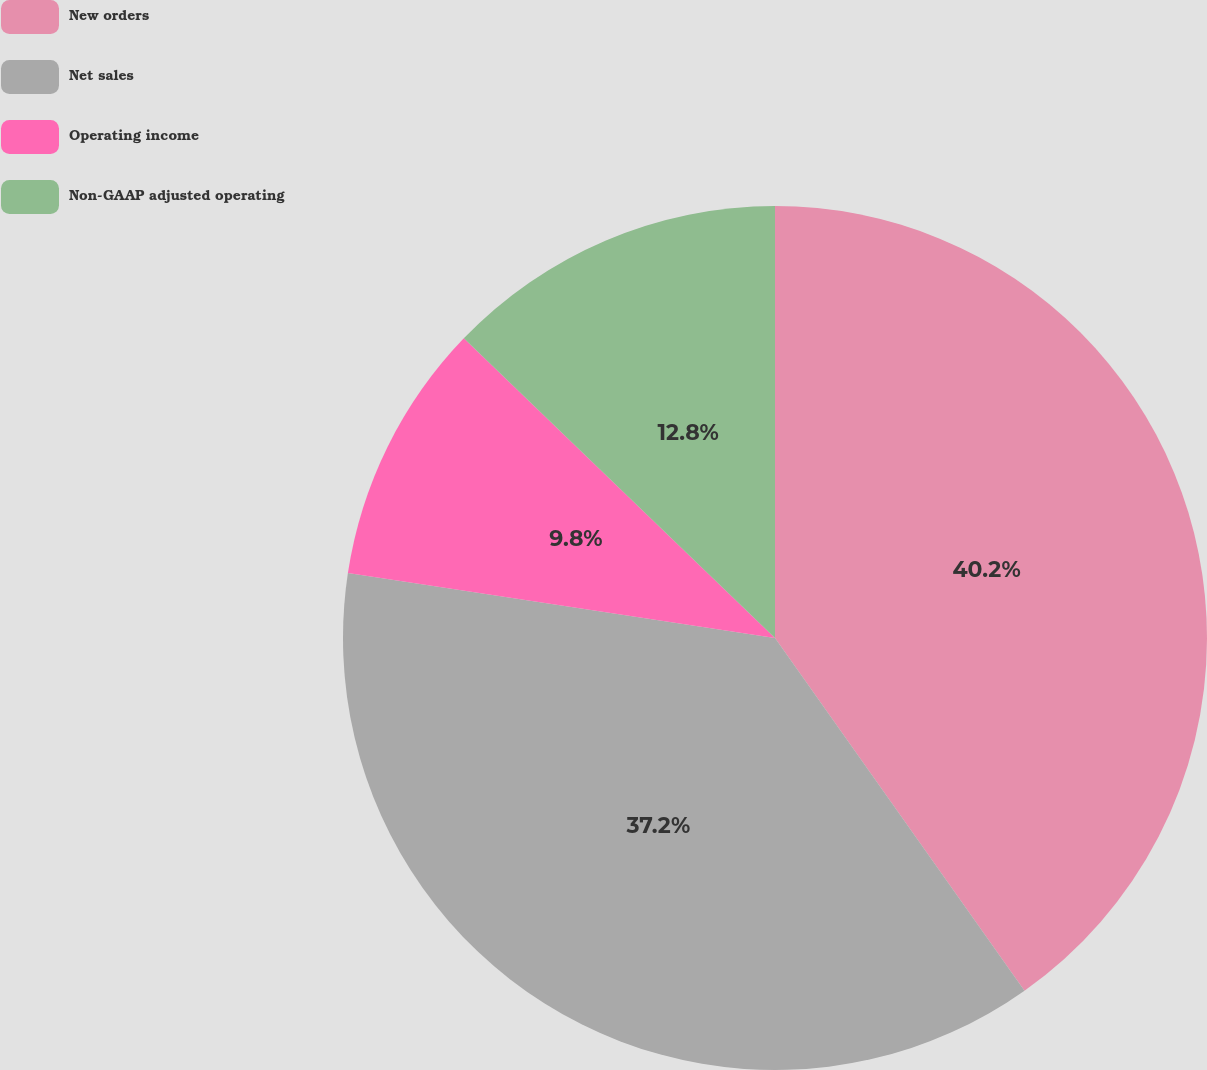<chart> <loc_0><loc_0><loc_500><loc_500><pie_chart><fcel>New orders<fcel>Net sales<fcel>Operating income<fcel>Non-GAAP adjusted operating<nl><fcel>40.2%<fcel>37.2%<fcel>9.8%<fcel>12.8%<nl></chart> 